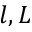<formula> <loc_0><loc_0><loc_500><loc_500>l , L</formula> 